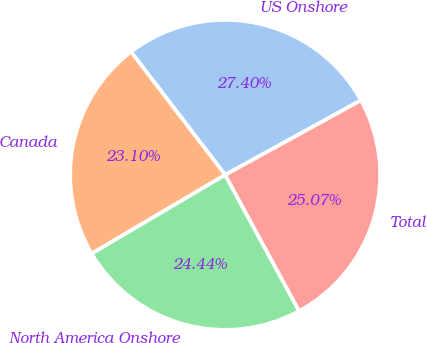Convert chart to OTSL. <chart><loc_0><loc_0><loc_500><loc_500><pie_chart><fcel>US Onshore<fcel>Canada<fcel>North America Onshore<fcel>Total<nl><fcel>27.4%<fcel>23.1%<fcel>24.44%<fcel>25.07%<nl></chart> 